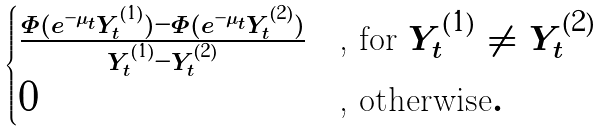<formula> <loc_0><loc_0><loc_500><loc_500>\begin{cases} \frac { \Phi ( e ^ { - \mu _ { t } } Y ^ { ( 1 ) } _ { t } ) - \Phi ( e ^ { - \mu _ { t } } Y ^ { ( 2 ) } _ { t } ) } { Y ^ { ( 1 ) } _ { t } - Y ^ { ( 2 ) } _ { t } } & \text {, for } Y ^ { ( 1 ) } _ { t } \ne Y ^ { ( 2 ) } _ { t } \\ 0 & \text {, otherwise} . \end{cases}</formula> 